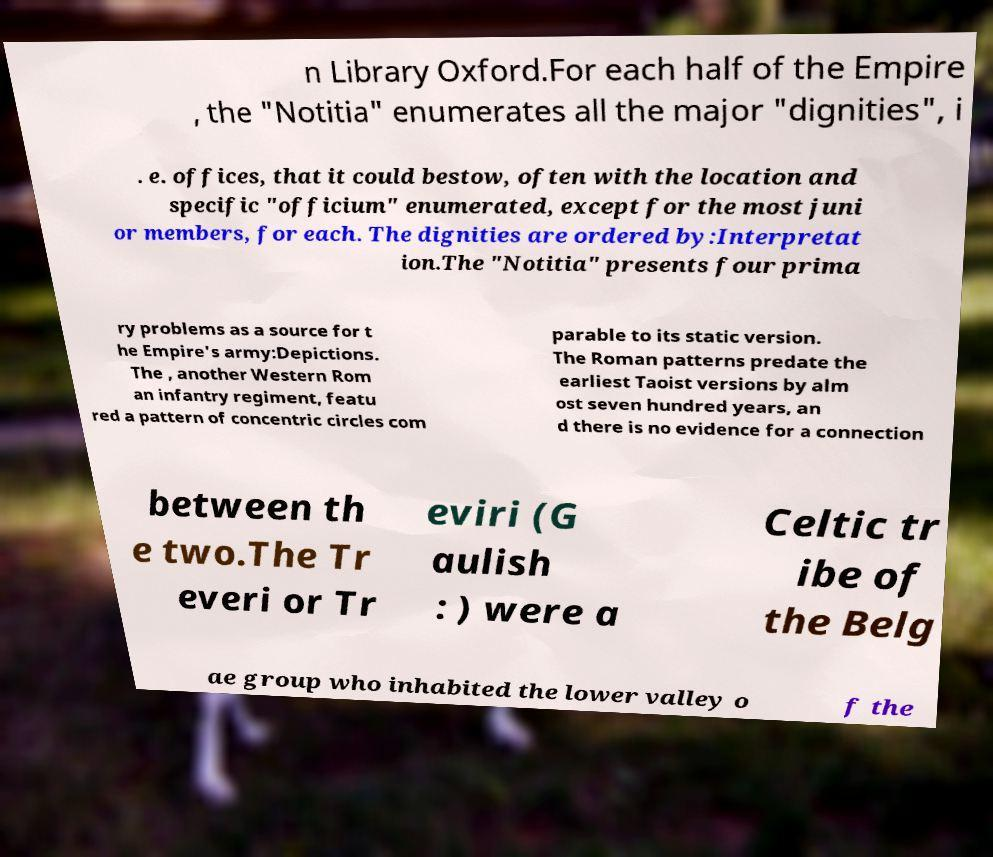Please read and relay the text visible in this image. What does it say? n Library Oxford.For each half of the Empire , the "Notitia" enumerates all the major "dignities", i . e. offices, that it could bestow, often with the location and specific "officium" enumerated, except for the most juni or members, for each. The dignities are ordered by:Interpretat ion.The "Notitia" presents four prima ry problems as a source for t he Empire's army:Depictions. The , another Western Rom an infantry regiment, featu red a pattern of concentric circles com parable to its static version. The Roman patterns predate the earliest Taoist versions by alm ost seven hundred years, an d there is no evidence for a connection between th e two.The Tr everi or Tr eviri (G aulish : ) were a Celtic tr ibe of the Belg ae group who inhabited the lower valley o f the 